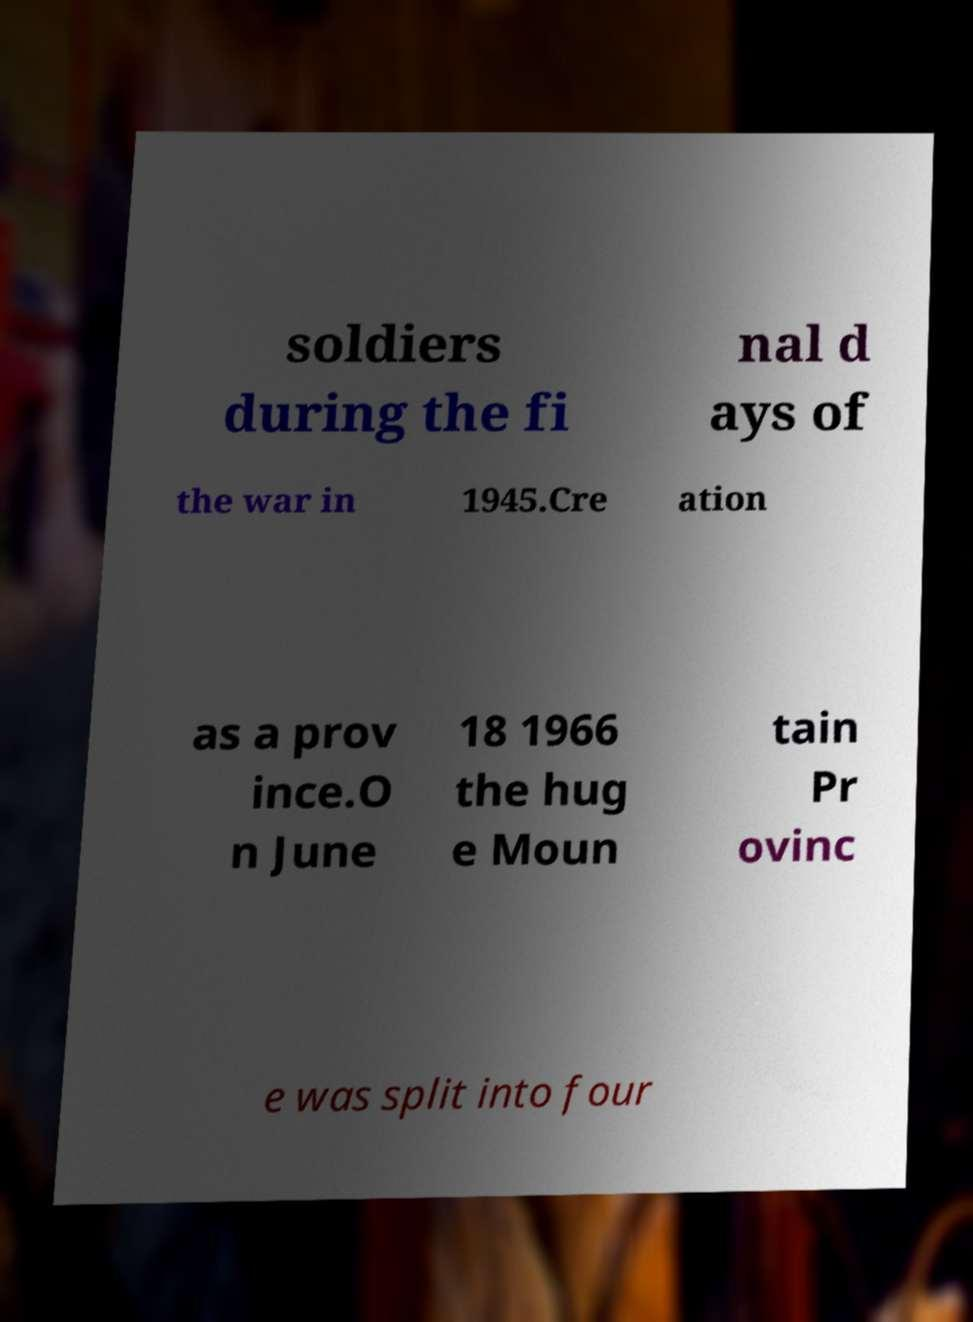Can you read and provide the text displayed in the image?This photo seems to have some interesting text. Can you extract and type it out for me? soldiers during the fi nal d ays of the war in 1945.Cre ation as a prov ince.O n June 18 1966 the hug e Moun tain Pr ovinc e was split into four 